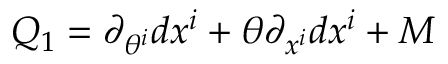<formula> <loc_0><loc_0><loc_500><loc_500>Q _ { 1 } = \partial _ { \theta ^ { i } } d x ^ { i } + \theta \partial _ { x ^ { i } } d x ^ { i } + M</formula> 